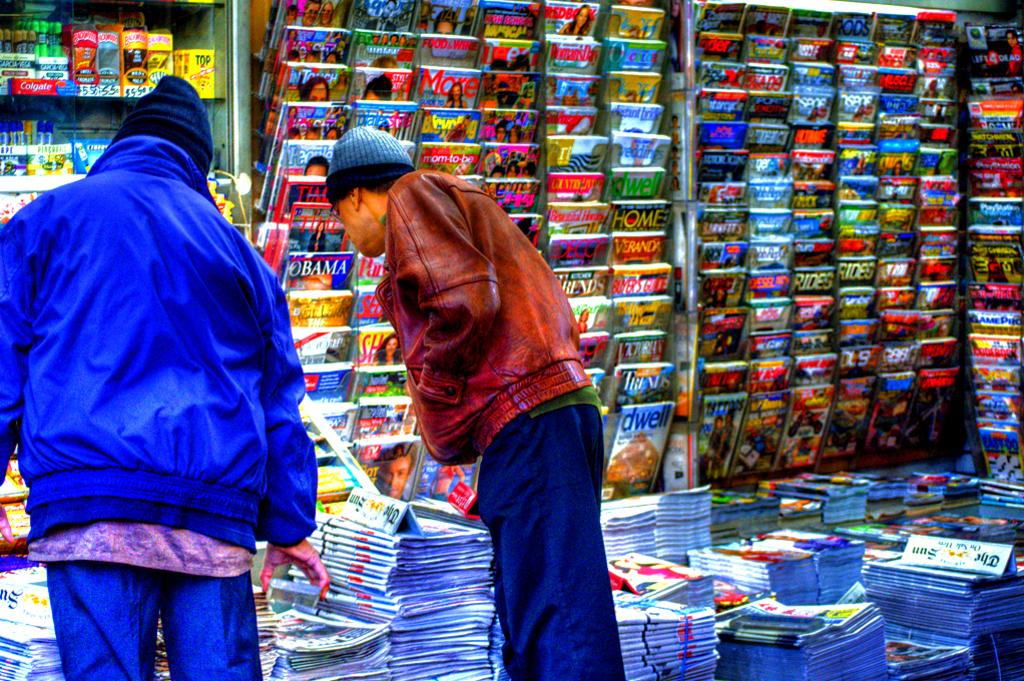<image>
Write a terse but informative summary of the picture. Two men standing in front of a magazine stand with titles that include "Time", "Obama", "Bycicling", and "TV Guide". 